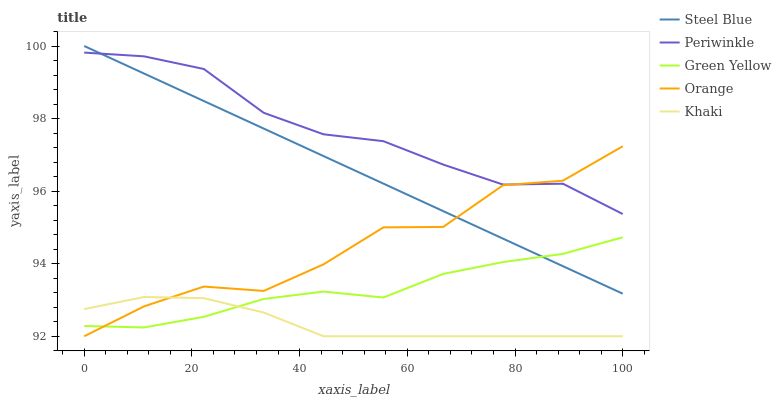Does Khaki have the minimum area under the curve?
Answer yes or no. Yes. Does Periwinkle have the maximum area under the curve?
Answer yes or no. Yes. Does Green Yellow have the minimum area under the curve?
Answer yes or no. No. Does Green Yellow have the maximum area under the curve?
Answer yes or no. No. Is Steel Blue the smoothest?
Answer yes or no. Yes. Is Orange the roughest?
Answer yes or no. Yes. Is Green Yellow the smoothest?
Answer yes or no. No. Is Green Yellow the roughest?
Answer yes or no. No. Does Orange have the lowest value?
Answer yes or no. Yes. Does Green Yellow have the lowest value?
Answer yes or no. No. Does Steel Blue have the highest value?
Answer yes or no. Yes. Does Green Yellow have the highest value?
Answer yes or no. No. Is Khaki less than Steel Blue?
Answer yes or no. Yes. Is Steel Blue greater than Khaki?
Answer yes or no. Yes. Does Orange intersect Khaki?
Answer yes or no. Yes. Is Orange less than Khaki?
Answer yes or no. No. Is Orange greater than Khaki?
Answer yes or no. No. Does Khaki intersect Steel Blue?
Answer yes or no. No. 